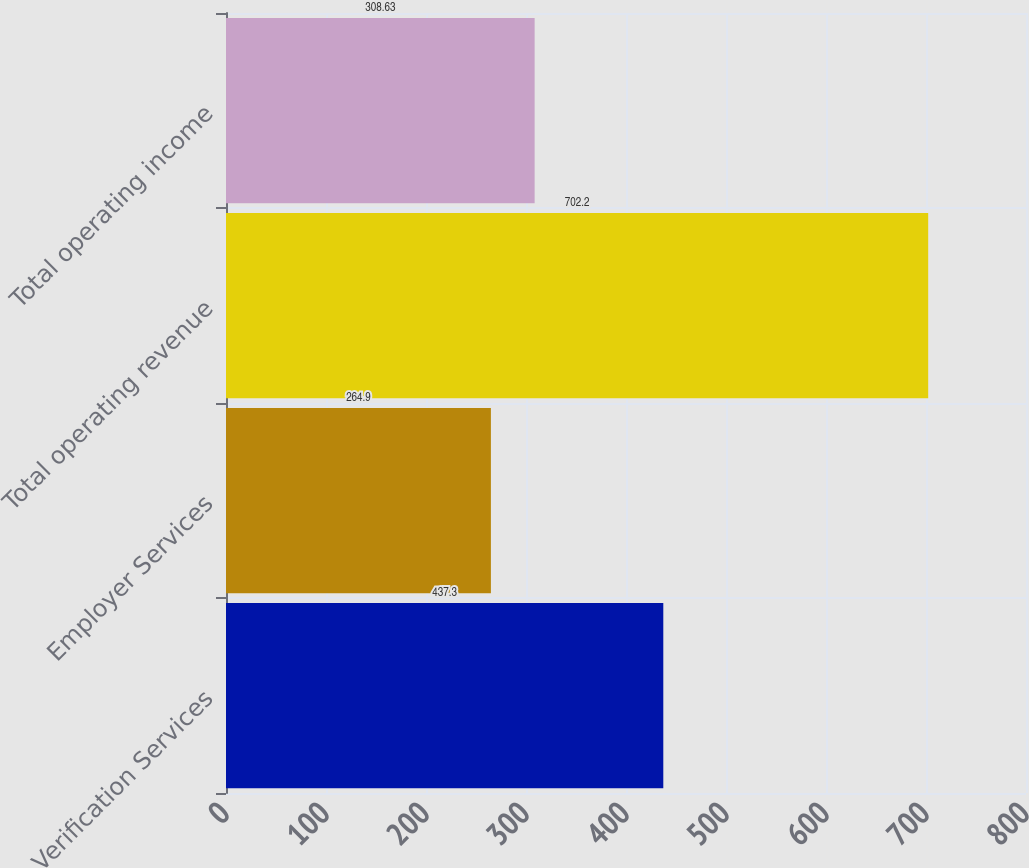Convert chart to OTSL. <chart><loc_0><loc_0><loc_500><loc_500><bar_chart><fcel>Verification Services<fcel>Employer Services<fcel>Total operating revenue<fcel>Total operating income<nl><fcel>437.3<fcel>264.9<fcel>702.2<fcel>308.63<nl></chart> 